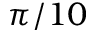<formula> <loc_0><loc_0><loc_500><loc_500>\pi / 1 0</formula> 